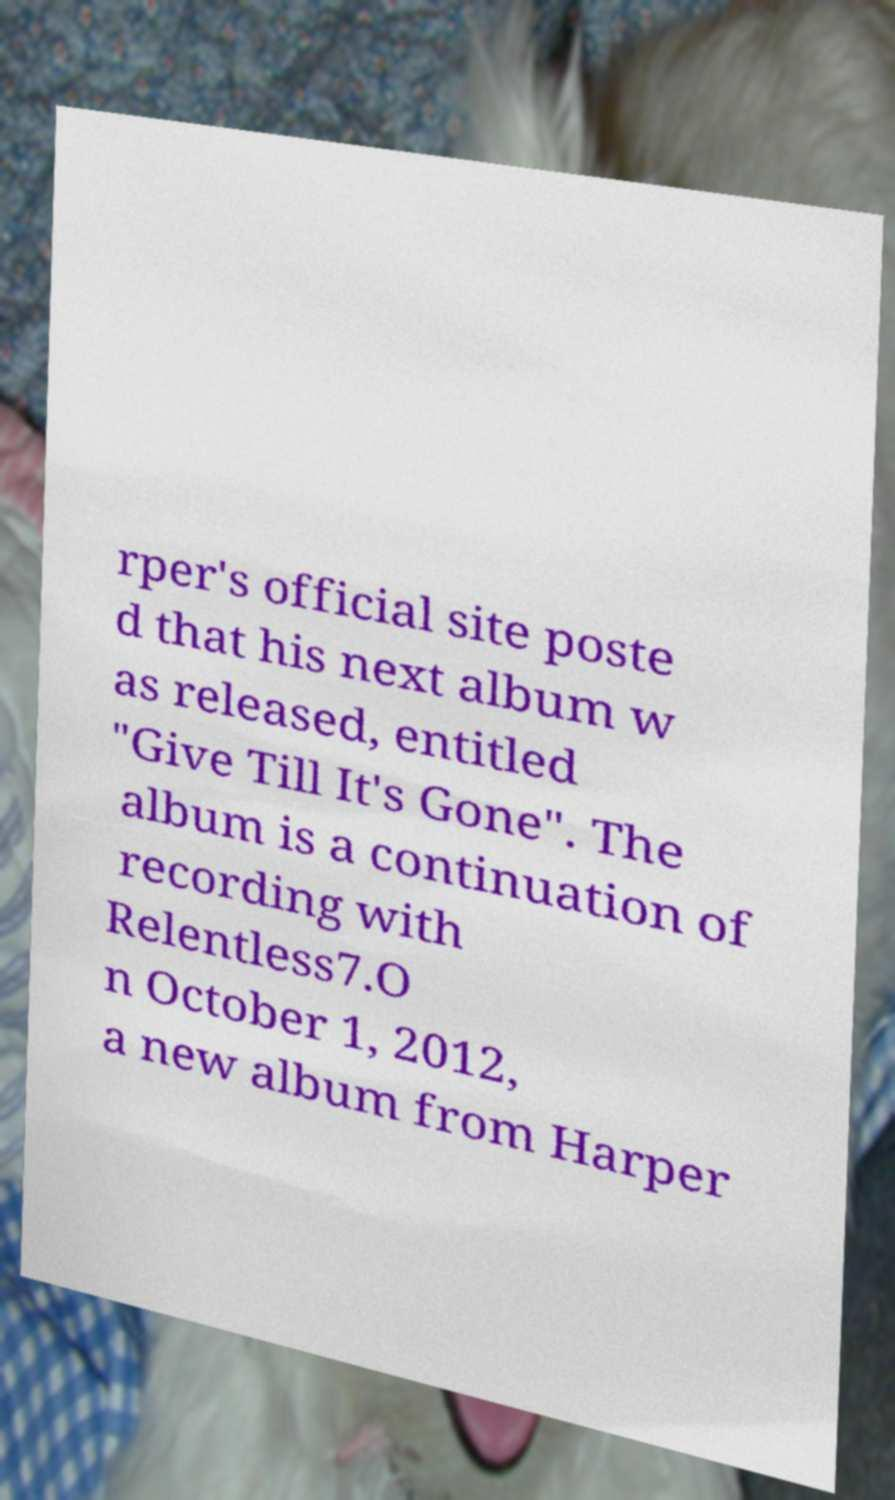Please read and relay the text visible in this image. What does it say? rper's official site poste d that his next album w as released, entitled "Give Till It's Gone". The album is a continuation of recording with Relentless7.O n October 1, 2012, a new album from Harper 